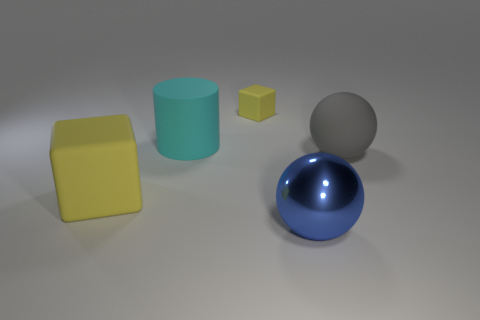How do the textures of the objects compare? The two cubes have a matte and slightly reflective texture, one more so than the other. The cylinder appears to have a smooth, almost velvety surface, while both spheres exhibit high reflectivity, yet they still differ as the smaller one seems to have a perfect mirror-like finish. 